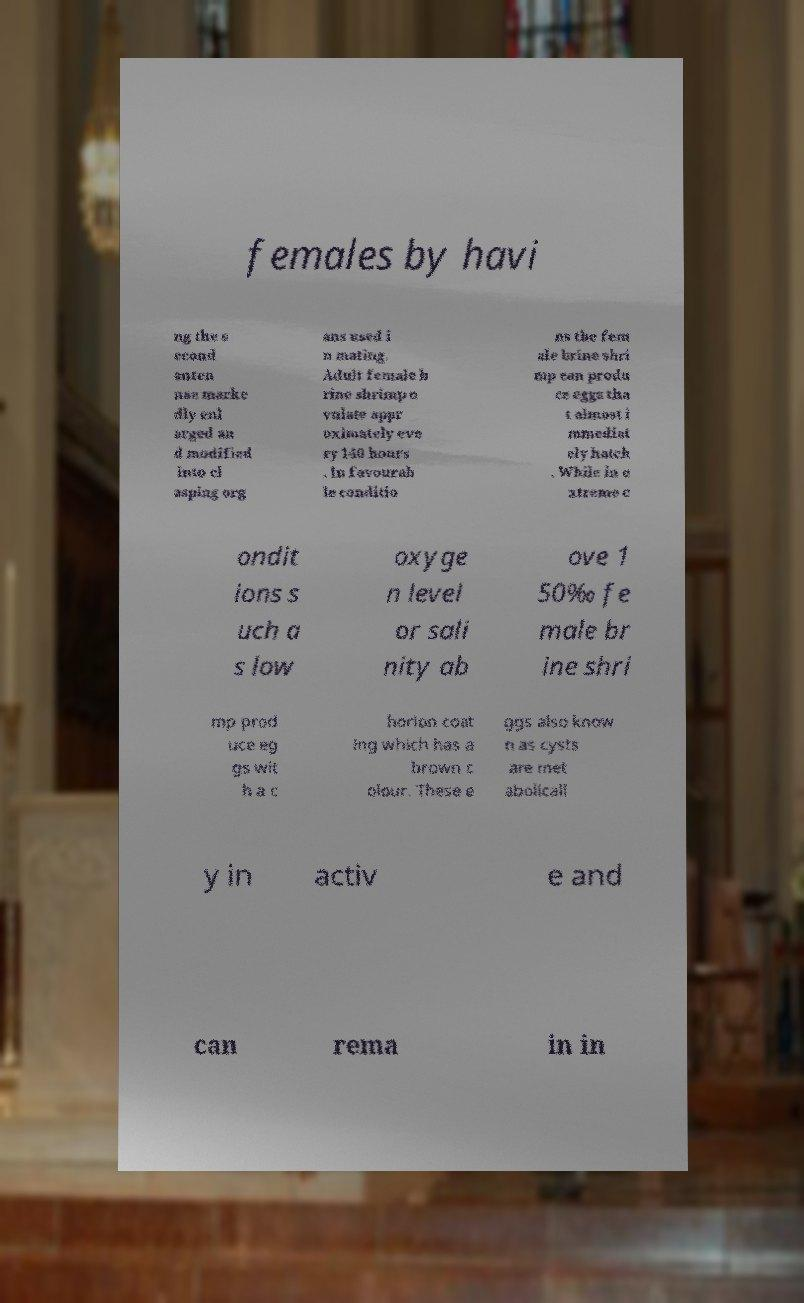Please identify and transcribe the text found in this image. females by havi ng the s econd anten nae marke dly enl arged an d modified into cl asping org ans used i n mating. Adult female b rine shrimp o vulate appr oximately eve ry 140 hours . In favourab le conditio ns the fem ale brine shri mp can produ ce eggs tha t almost i mmediat ely hatch . While in e xtreme c ondit ions s uch a s low oxyge n level or sali nity ab ove 1 50‰ fe male br ine shri mp prod uce eg gs wit h a c horion coat ing which has a brown c olour. These e ggs also know n as cysts are met abolicall y in activ e and can rema in in 